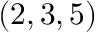Convert formula to latex. <formula><loc_0><loc_0><loc_500><loc_500>( 2 , 3 , 5 )</formula> 